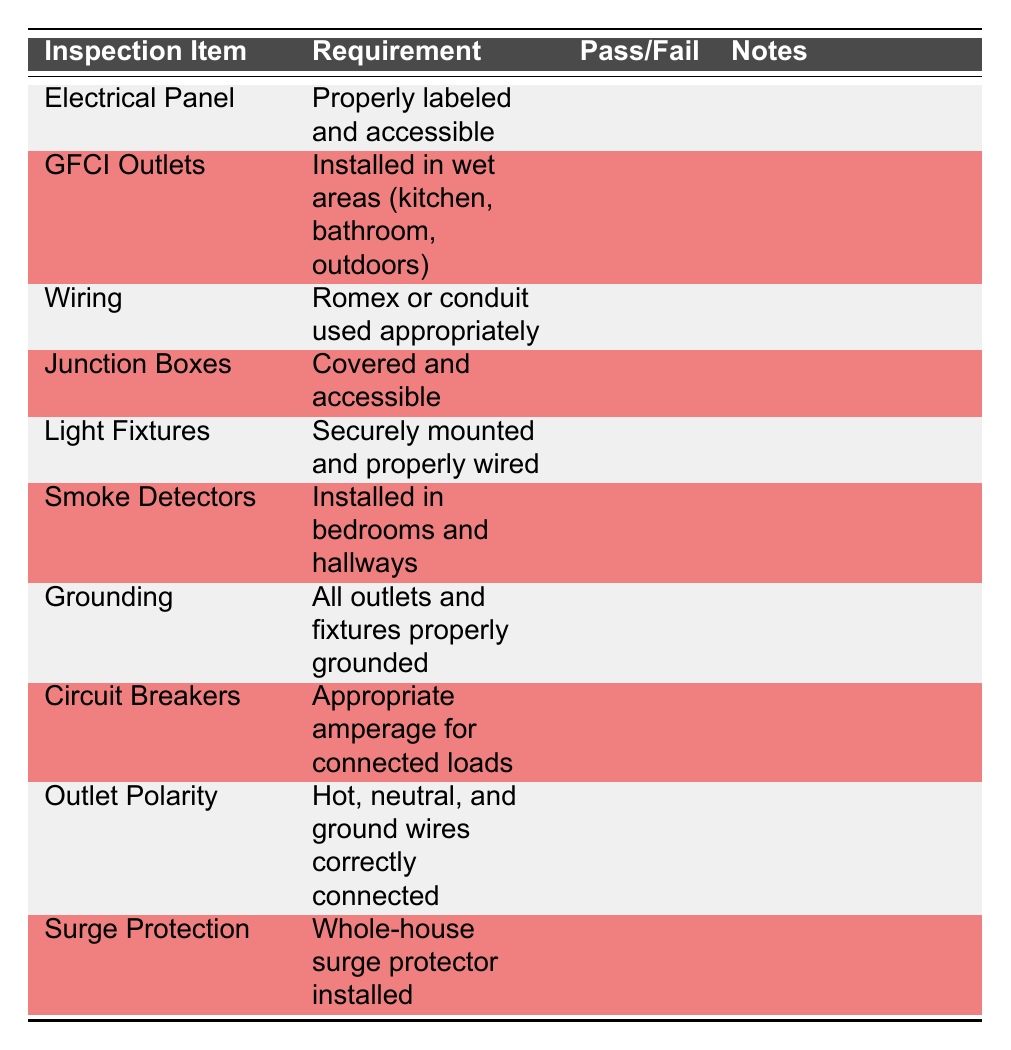What is the requirement for GFCI outlets? The table shows that GFCI outlets need to be installed in wet areas such as the kitchen, bathroom, and outdoors.
Answer: Installed in wet areas (kitchen, bathroom, outdoors) Are smoke detectors required in hallways? The requirement listed in the table states that smoke detectors should be installed in bedrooms and hallways. Therefore, the answer is yes.
Answer: Yes How many total inspection items are listed in the table? The table lists 10 inspection items as seen from the rows provided.
Answer: 10 What does the electrical panel need to be? The electrical panel must be properly labeled and accessible according to the table.
Answer: Properly labeled and accessible Are all outlets and fixtures required to be grounded? The table states that all outlets and fixtures must be properly grounded. Therefore, the answer is yes.
Answer: Yes Which inspection item requires a whole-house surge protector? The requirement for a whole-house surge protector is specified under the Surge Protection item in the table.
Answer: Whole-house surge protector What is the requirement for wiring? The wiring requirement is stated as using Romex or conduit appropriately, as shown in the table.
Answer: Romex or conduit used appropriately If a house has installed GFCI outlets and properly grounded fixtures, does it meet the requirements based on the checklist? The checklist specifies that GFCI outlets should be installed in wet areas and all outlets and fixtures must be grounded. Since both are satisfied, it meets the requirements.
Answer: Yes What inspection items have notes and pass/fail columns that are empty? All inspection items in the table currently have empty notes and pass/fail columns; therefore, all items listed are applicable.
Answer: All items listed are applicable 